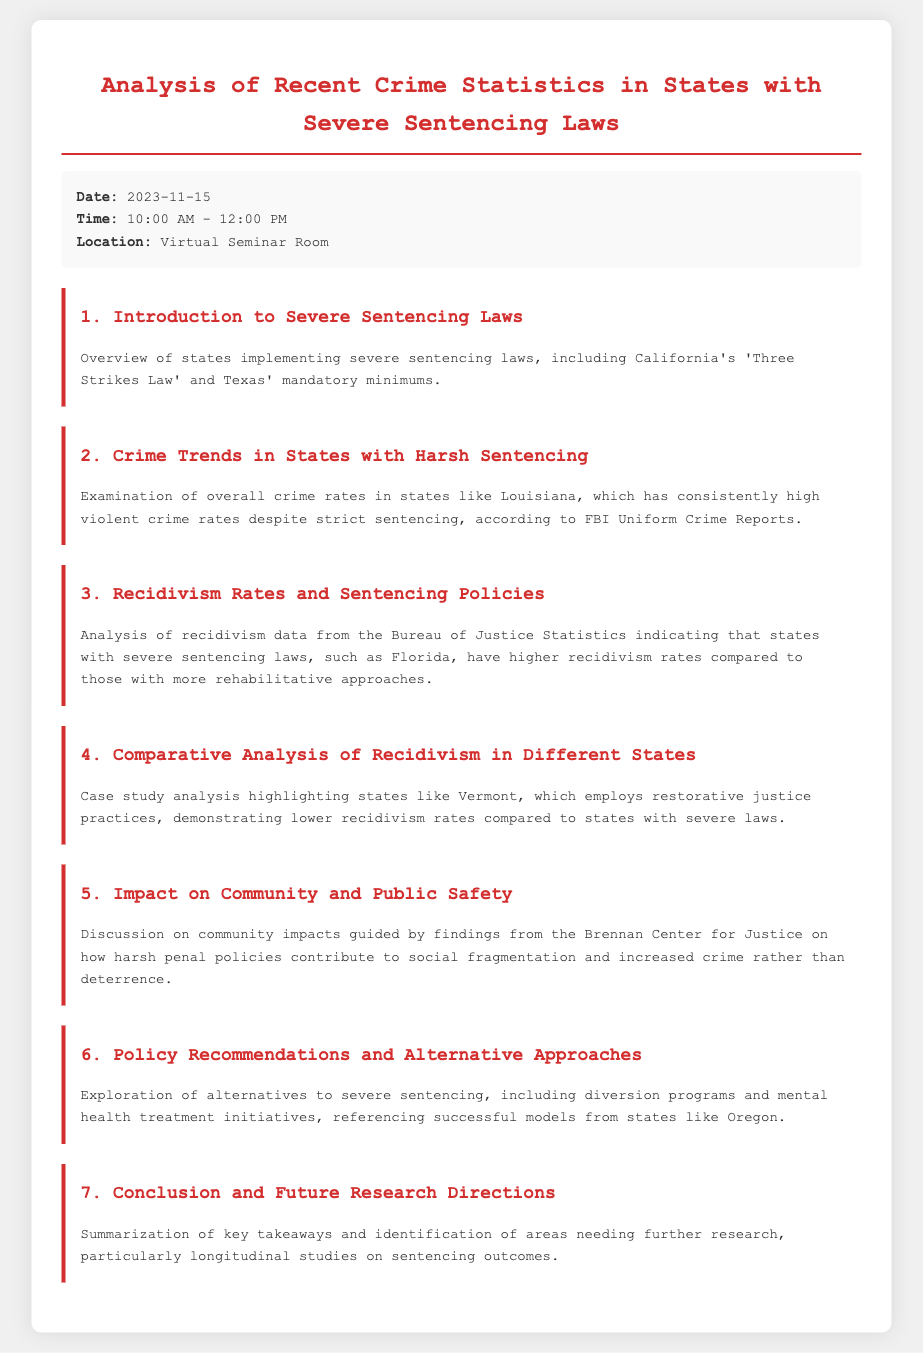What is the title of the document? The title is the main heading of the document, indicating the focus of the analysis.
Answer: Analysis of Recent Crime Statistics in States with Severe Sentencing Laws What date is the seminar scheduled? The date is specified in the meta-info section as the date for the seminar.
Answer: 2023-11-15 Which state is mentioned as having a 'Three Strikes Law'? This law is discussed in the context of severe sentencing laws within the introductory topic.
Answer: California What is highlighted as a state with high violent crime rates? This state is used as an example of high crime rates despite strict policies in the crime trends topic.
Answer: Louisiana Which Bureau is cited for recidivism data? The source of the recidivism statistics is specified in the related analysis topic.
Answer: Bureau of Justice Statistics What type of justice practices does Vermont employ? The practices are mentioned in the comparative analysis of recidivism rates.
Answer: Restorative justice What organization provided findings on community impacts? The organization is referenced in the discussion about the effects of harsh penal policies on communities.
Answer: Brennan Center for Justice What alternative approach is mentioned for severe sentencing? The document discusses this alternative within the policy recommendations topic.
Answer: Diversion programs How long is the seminar scheduled to last? The duration can be calculated based on the starting and ending time provided in the meta-info.
Answer: 2 hours 